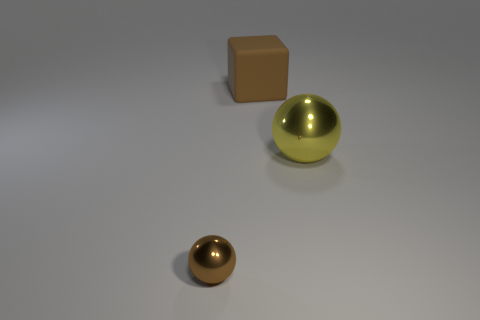There is a object in front of the large metallic thing; is its color the same as the object right of the large brown rubber object? No, the object in front of the large metallic sphere is smaller and has a bronze hue, which contrasts with the silver hue of the object to the right of the large brown rubber cube. 